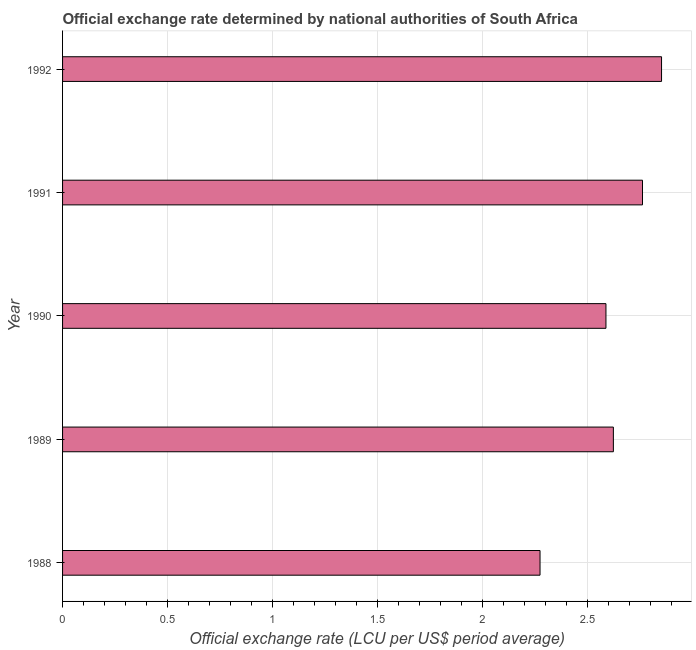Does the graph contain grids?
Offer a terse response. Yes. What is the title of the graph?
Offer a terse response. Official exchange rate determined by national authorities of South Africa. What is the label or title of the X-axis?
Your response must be concise. Official exchange rate (LCU per US$ period average). What is the label or title of the Y-axis?
Your response must be concise. Year. What is the official exchange rate in 1991?
Offer a terse response. 2.76. Across all years, what is the maximum official exchange rate?
Keep it short and to the point. 2.85. Across all years, what is the minimum official exchange rate?
Provide a succinct answer. 2.27. What is the sum of the official exchange rate?
Give a very brief answer. 13.1. What is the difference between the official exchange rate in 1988 and 1989?
Provide a short and direct response. -0.35. What is the average official exchange rate per year?
Your answer should be compact. 2.62. What is the median official exchange rate?
Make the answer very short. 2.62. Is the difference between the official exchange rate in 1988 and 1992 greater than the difference between any two years?
Offer a very short reply. Yes. What is the difference between the highest and the second highest official exchange rate?
Give a very brief answer. 0.09. Is the sum of the official exchange rate in 1988 and 1989 greater than the maximum official exchange rate across all years?
Your response must be concise. Yes. What is the difference between the highest and the lowest official exchange rate?
Your answer should be compact. 0.58. In how many years, is the official exchange rate greater than the average official exchange rate taken over all years?
Provide a succinct answer. 3. How many years are there in the graph?
Make the answer very short. 5. What is the difference between two consecutive major ticks on the X-axis?
Provide a short and direct response. 0.5. What is the Official exchange rate (LCU per US$ period average) in 1988?
Your response must be concise. 2.27. What is the Official exchange rate (LCU per US$ period average) in 1989?
Offer a very short reply. 2.62. What is the Official exchange rate (LCU per US$ period average) of 1990?
Make the answer very short. 2.59. What is the Official exchange rate (LCU per US$ period average) of 1991?
Offer a very short reply. 2.76. What is the Official exchange rate (LCU per US$ period average) of 1992?
Your answer should be compact. 2.85. What is the difference between the Official exchange rate (LCU per US$ period average) in 1988 and 1989?
Give a very brief answer. -0.35. What is the difference between the Official exchange rate (LCU per US$ period average) in 1988 and 1990?
Give a very brief answer. -0.31. What is the difference between the Official exchange rate (LCU per US$ period average) in 1988 and 1991?
Keep it short and to the point. -0.49. What is the difference between the Official exchange rate (LCU per US$ period average) in 1988 and 1992?
Your response must be concise. -0.58. What is the difference between the Official exchange rate (LCU per US$ period average) in 1989 and 1990?
Offer a very short reply. 0.04. What is the difference between the Official exchange rate (LCU per US$ period average) in 1989 and 1991?
Give a very brief answer. -0.14. What is the difference between the Official exchange rate (LCU per US$ period average) in 1989 and 1992?
Your answer should be very brief. -0.23. What is the difference between the Official exchange rate (LCU per US$ period average) in 1990 and 1991?
Your response must be concise. -0.17. What is the difference between the Official exchange rate (LCU per US$ period average) in 1990 and 1992?
Offer a terse response. -0.26. What is the difference between the Official exchange rate (LCU per US$ period average) in 1991 and 1992?
Keep it short and to the point. -0.09. What is the ratio of the Official exchange rate (LCU per US$ period average) in 1988 to that in 1989?
Offer a very short reply. 0.87. What is the ratio of the Official exchange rate (LCU per US$ period average) in 1988 to that in 1990?
Provide a short and direct response. 0.88. What is the ratio of the Official exchange rate (LCU per US$ period average) in 1988 to that in 1991?
Keep it short and to the point. 0.82. What is the ratio of the Official exchange rate (LCU per US$ period average) in 1988 to that in 1992?
Offer a terse response. 0.8. What is the ratio of the Official exchange rate (LCU per US$ period average) in 1989 to that in 1992?
Give a very brief answer. 0.92. What is the ratio of the Official exchange rate (LCU per US$ period average) in 1990 to that in 1991?
Provide a succinct answer. 0.94. What is the ratio of the Official exchange rate (LCU per US$ period average) in 1990 to that in 1992?
Make the answer very short. 0.91. 